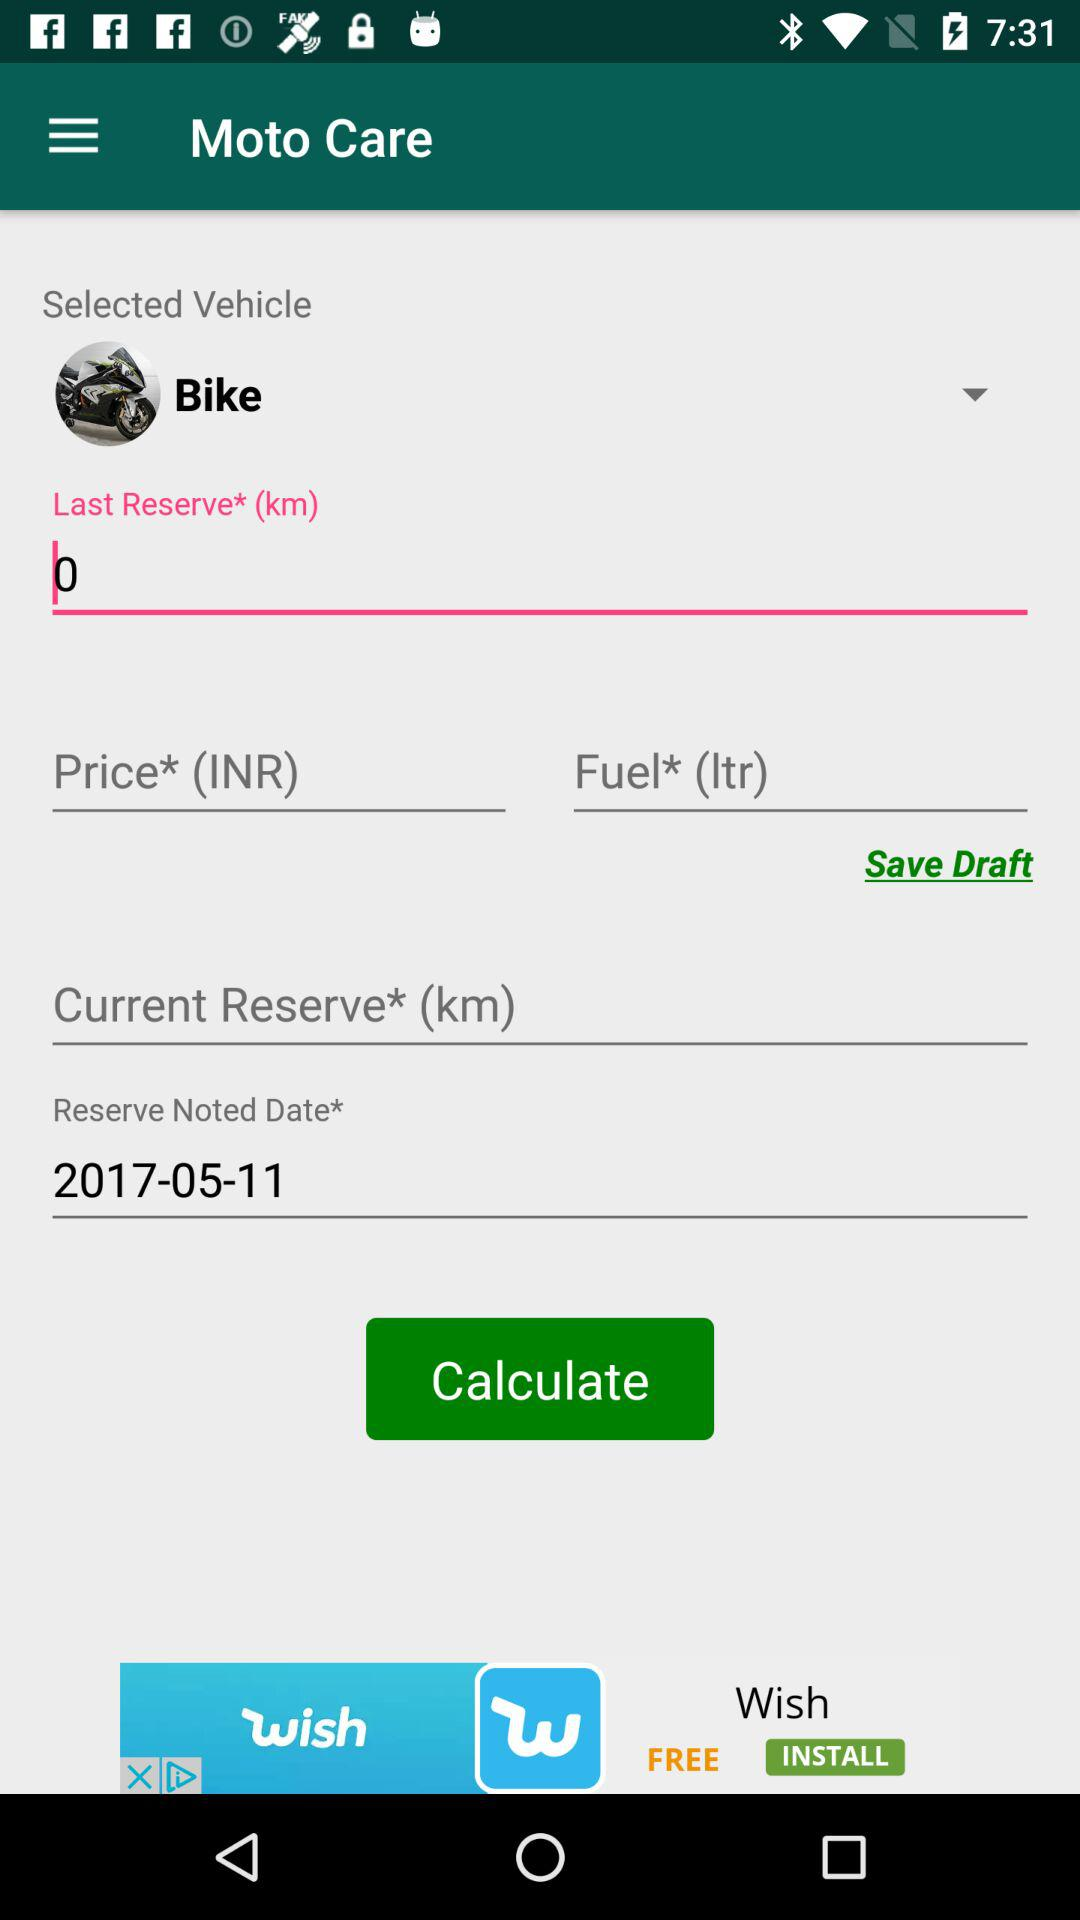Which vehicle is selected? The selected vehicle is the bike. 